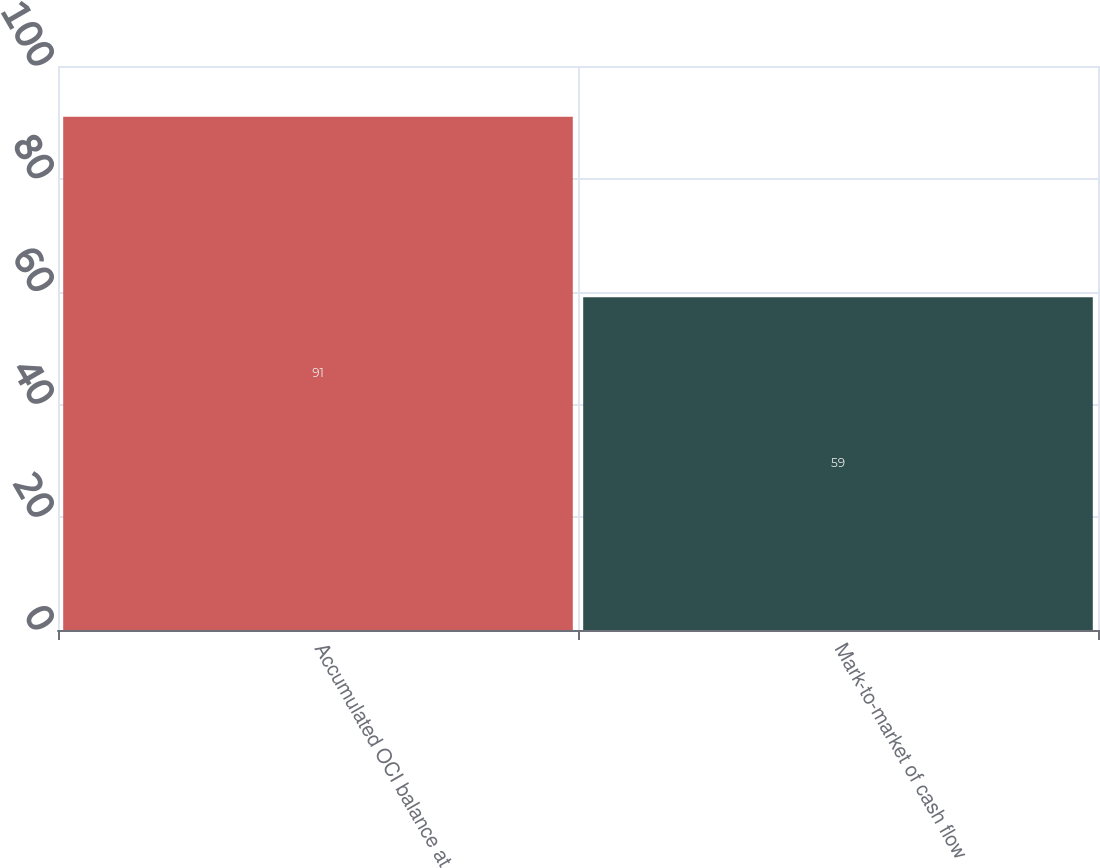<chart> <loc_0><loc_0><loc_500><loc_500><bar_chart><fcel>Accumulated OCI balance at<fcel>Mark-to-market of cash flow<nl><fcel>91<fcel>59<nl></chart> 